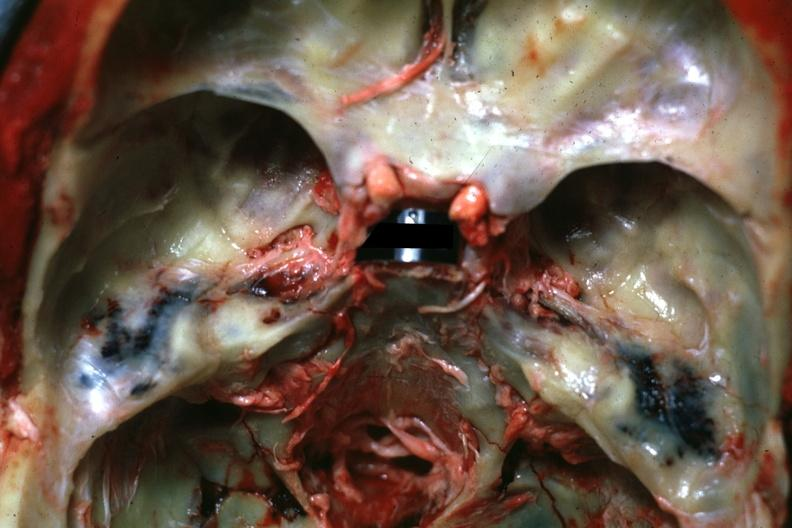does this image show view of middle ear areas with obvious hemorrhage in under-lying tissue?
Answer the question using a single word or phrase. Yes 